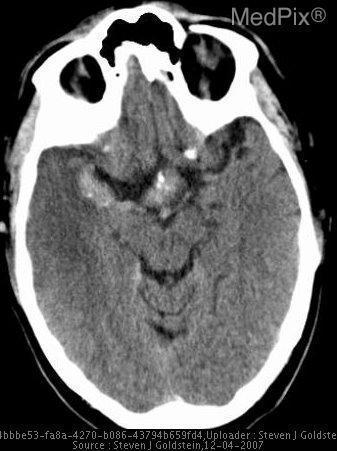Is there edema in the patient's right temporal lobe?
Quick response, please. Yes. Is there evidence of cytotoxic edema in the right temporal lobe?
Be succinct. Yes. Are the orbits in view of this image?
Concise answer only. Yes. Is there blurring of the grey-white matter junctions in the right temporal lobe?
Write a very short answer. Yes. Is there no definitive border between the grey matter and white matter in the right temporal lobe?
Concise answer only. Yes. Are there calcifications in the cerebral arteries?
Be succinct. Yes. Is there evidence of calcifications in the cerebral arteries?
Concise answer only. Yes. 